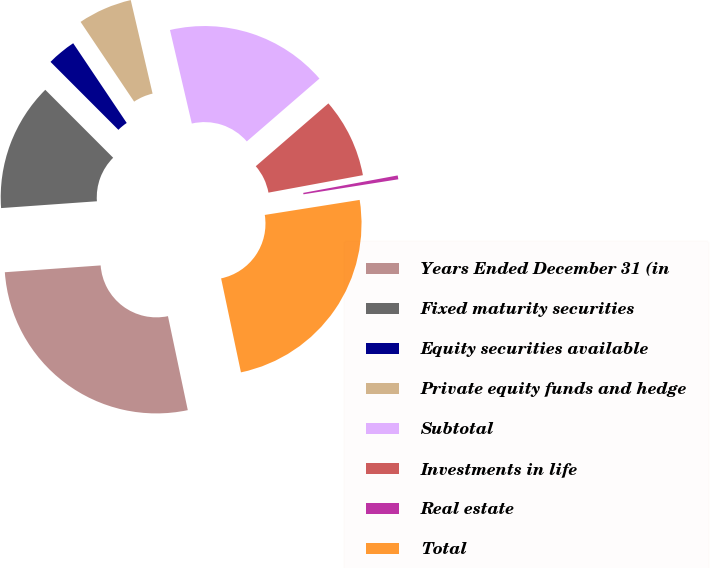Convert chart to OTSL. <chart><loc_0><loc_0><loc_500><loc_500><pie_chart><fcel>Years Ended December 31 (in<fcel>Fixed maturity securities<fcel>Equity securities available<fcel>Private equity funds and hedge<fcel>Subtotal<fcel>Investments in life<fcel>Real estate<fcel>Total<nl><fcel>27.18%<fcel>13.64%<fcel>3.08%<fcel>5.76%<fcel>17.3%<fcel>8.44%<fcel>0.41%<fcel>24.19%<nl></chart> 